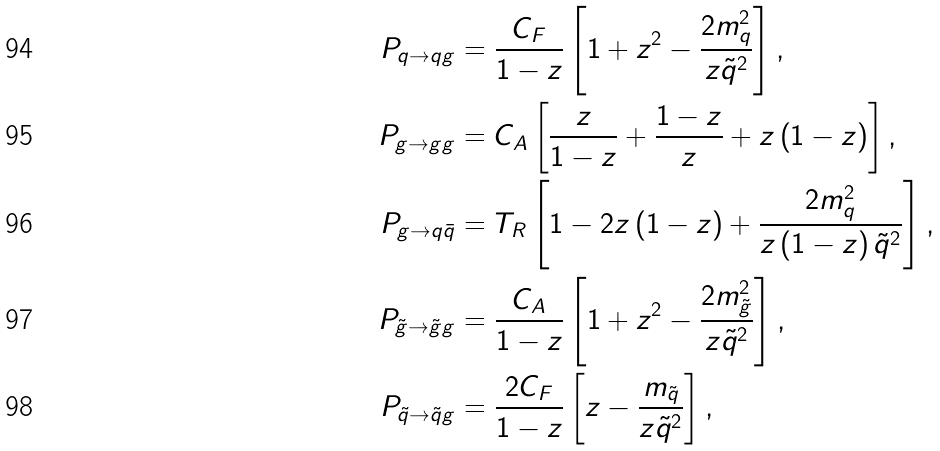<formula> <loc_0><loc_0><loc_500><loc_500>P _ { q \to q g } & = \frac { C _ { F } } { 1 - z } \left [ 1 + z ^ { 2 } - \frac { 2 m _ { q } ^ { 2 } } { z \tilde { q } ^ { 2 } } \right ] , \\ P _ { g \to g g } & = C _ { A } \left [ \frac { z } { 1 - z } + \frac { 1 - z } { z } + z \left ( 1 - z \right ) \right ] , \\ P _ { g \to q \bar { q } } & = T _ { R } \left [ 1 - 2 z \left ( 1 - z \right ) + \frac { 2 m _ { q } ^ { 2 } } { z \left ( 1 - z \right ) \tilde { q } ^ { 2 } } \right ] , \\ P _ { \tilde { g } \to \tilde { g } g } & = \frac { C _ { A } } { 1 - z } \left [ 1 + z ^ { 2 } - \frac { 2 m _ { \tilde { g } } ^ { 2 } } { z \tilde { q } ^ { 2 } } \right ] , \\ P _ { \tilde { q } \to \tilde { q } g } & = \frac { 2 C _ { F } } { 1 - z } \left [ z - \frac { m _ { \tilde { q } } } { z \tilde { q } ^ { 2 } } \right ] ,</formula> 